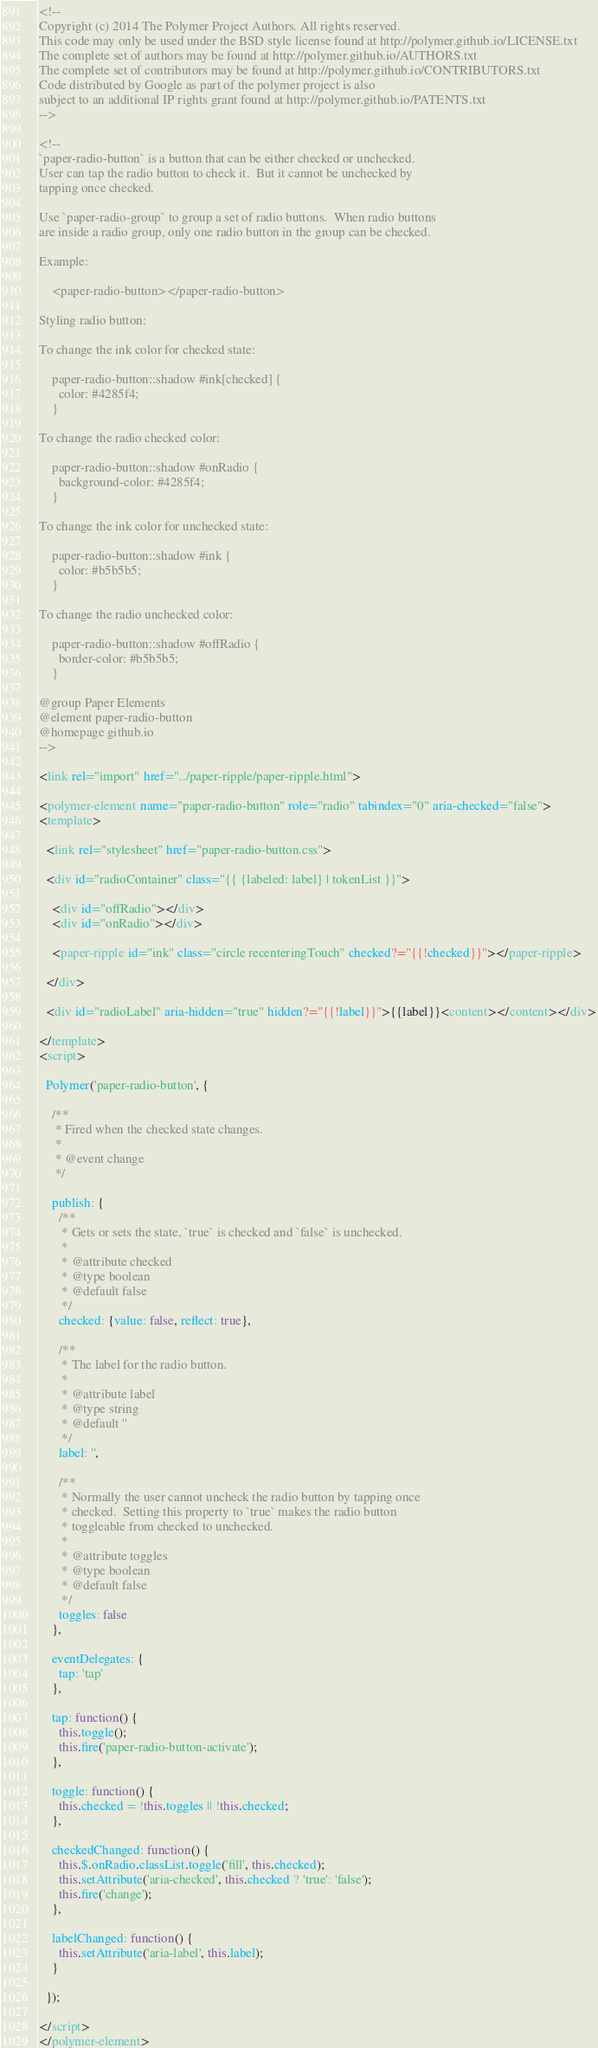<code> <loc_0><loc_0><loc_500><loc_500><_HTML_><!--
Copyright (c) 2014 The Polymer Project Authors. All rights reserved.
This code may only be used under the BSD style license found at http://polymer.github.io/LICENSE.txt
The complete set of authors may be found at http://polymer.github.io/AUTHORS.txt
The complete set of contributors may be found at http://polymer.github.io/CONTRIBUTORS.txt
Code distributed by Google as part of the polymer project is also
subject to an additional IP rights grant found at http://polymer.github.io/PATENTS.txt
-->

<!--
`paper-radio-button` is a button that can be either checked or unchecked.
User can tap the radio button to check it.  But it cannot be unchecked by
tapping once checked.

Use `paper-radio-group` to group a set of radio buttons.  When radio buttons
are inside a radio group, only one radio button in the group can be checked.

Example:

    <paper-radio-button></paper-radio-button>
    
Styling radio button:

To change the ink color for checked state:

    paper-radio-button::shadow #ink[checked] {
      color: #4285f4;
    }
    
To change the radio checked color:
    
    paper-radio-button::shadow #onRadio {
      background-color: #4285f4;
    }
    
To change the ink color for unchecked state:

    paper-radio-button::shadow #ink {
      color: #b5b5b5;
    }
    
To change the radio unchecked color:
    
    paper-radio-button::shadow #offRadio {
      border-color: #b5b5b5;
    }

@group Paper Elements
@element paper-radio-button
@homepage github.io
-->

<link rel="import" href="../paper-ripple/paper-ripple.html">

<polymer-element name="paper-radio-button" role="radio" tabindex="0" aria-checked="false">
<template>

  <link rel="stylesheet" href="paper-radio-button.css">
  
  <div id="radioContainer" class="{{ {labeled: label} | tokenList }}">
  
    <div id="offRadio"></div>
    <div id="onRadio"></div>
    
    <paper-ripple id="ink" class="circle recenteringTouch" checked?="{{!checked}}"></paper-ripple>
    
  </div>
  
  <div id="radioLabel" aria-hidden="true" hidden?="{{!label}}">{{label}}<content></content></div>
  
</template>
<script>

  Polymer('paper-radio-button', {
    
    /**
     * Fired when the checked state changes.
     *
     * @event change
     */
    
    publish: {
      /**
       * Gets or sets the state, `true` is checked and `false` is unchecked.
       *
       * @attribute checked
       * @type boolean
       * @default false
       */
      checked: {value: false, reflect: true},
      
      /**
       * The label for the radio button.
       *
       * @attribute label
       * @type string
       * @default ''
       */
      label: '',
      
      /**
       * Normally the user cannot uncheck the radio button by tapping once
       * checked.  Setting this property to `true` makes the radio button
       * toggleable from checked to unchecked.
       *
       * @attribute toggles
       * @type boolean
       * @default false
       */
      toggles: false
    },
    
    eventDelegates: {
      tap: 'tap'
    },
    
    tap: function() {
      this.toggle();
      this.fire('paper-radio-button-activate');
    },
    
    toggle: function() {
      this.checked = !this.toggles || !this.checked;
    },
    
    checkedChanged: function() {
      this.$.onRadio.classList.toggle('fill', this.checked);
      this.setAttribute('aria-checked', this.checked ? 'true': 'false');
      this.fire('change');
    },
    
    labelChanged: function() {
      this.setAttribute('aria-label', this.label);
    }
    
  });
  
</script>
</polymer-element>
</code> 